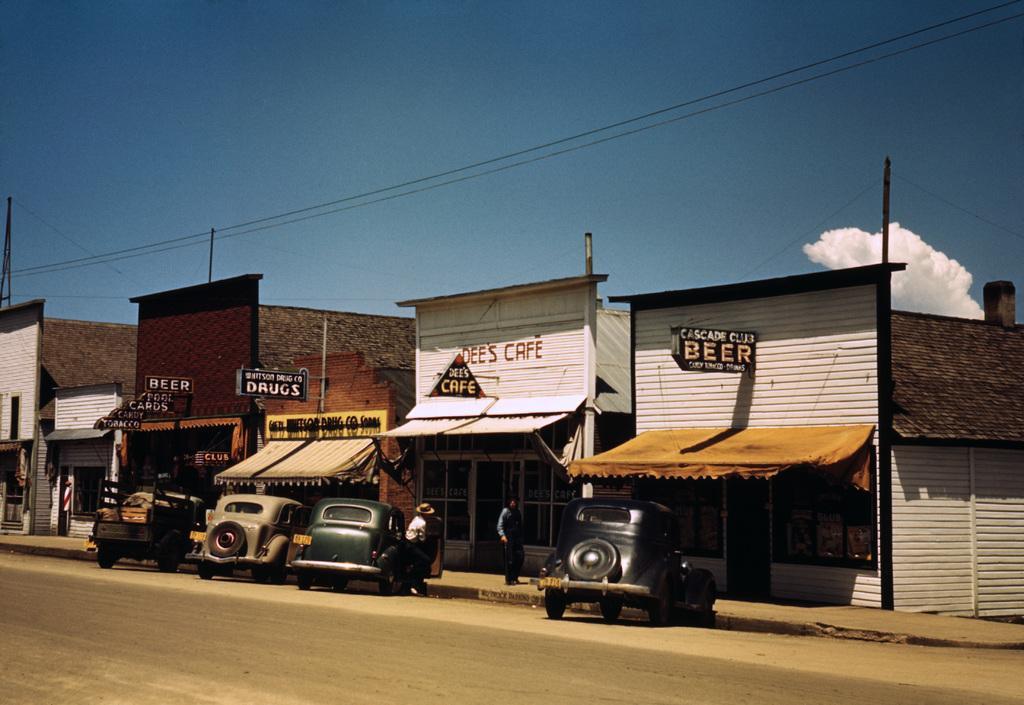In one or two sentences, can you explain what this image depicts? In this picture we can see some stores, there are cars parked in front of stores, we can see hoardings here, there are some wires here, we can see the sky at the top of the picture, there are two persons standing. 